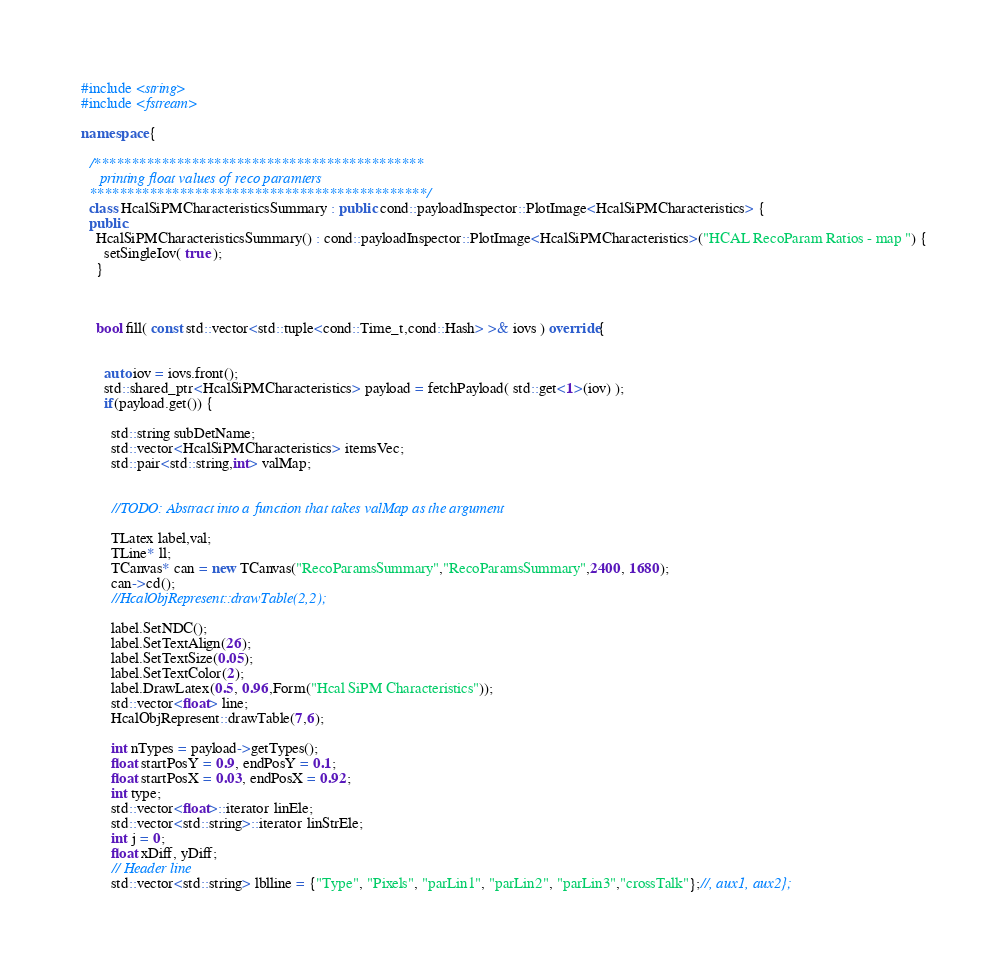Convert code to text. <code><loc_0><loc_0><loc_500><loc_500><_C++_>#include <string>
#include <fstream>

namespace {

  /********************************************
     printing float values of reco paramters
  *********************************************/
  class HcalSiPMCharacteristicsSummary : public cond::payloadInspector::PlotImage<HcalSiPMCharacteristics> {
  public:
    HcalSiPMCharacteristicsSummary() : cond::payloadInspector::PlotImage<HcalSiPMCharacteristics>("HCAL RecoParam Ratios - map ") {
      setSingleIov( true );
    }



    bool fill( const std::vector<std::tuple<cond::Time_t,cond::Hash> >& iovs ) override{
      

      auto iov = iovs.front();
      std::shared_ptr<HcalSiPMCharacteristics> payload = fetchPayload( std::get<1>(iov) );
      if(payload.get()) {
        
        std::string subDetName;
        std::vector<HcalSiPMCharacteristics> itemsVec;
        std::pair<std::string,int> valMap;


        //TODO: Abstract into a function that takes valMap as the argument
 
        TLatex label,val;
        TLine* ll;
        TCanvas* can = new TCanvas("RecoParamsSummary","RecoParamsSummary",2400, 1680);
        can->cd();
        //HcalObjRepresent::drawTable(2,2);

        label.SetNDC();
        label.SetTextAlign(26);
        label.SetTextSize(0.05);
        label.SetTextColor(2);
        label.DrawLatex(0.5, 0.96,Form("Hcal SiPM Characteristics"));
        std::vector<float> line;
        HcalObjRepresent::drawTable(7,6);
 
        int nTypes = payload->getTypes();
        float startPosY = 0.9, endPosY = 0.1;
        float startPosX = 0.03, endPosX = 0.92;
        int type;
        std::vector<float>::iterator linEle;
        std::vector<std::string>::iterator linStrEle;
        int j = 0;
        float xDiff, yDiff;
        // Header line
        std::vector<std::string> lblline = {"Type", "Pixels", "parLin1", "parLin2", "parLin3","crossTalk"};//, aux1, aux2};</code> 